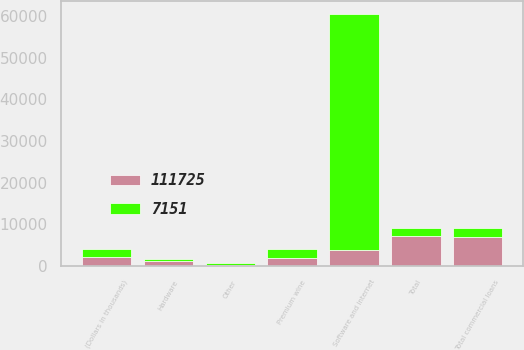Convert chart. <chart><loc_0><loc_0><loc_500><loc_500><stacked_bar_chart><ecel><fcel>(Dollars in thousands)<fcel>Software and internet<fcel>Hardware<fcel>Premium wine<fcel>Other<fcel>Total commercial loans<fcel>Total<nl><fcel>7151<fcel>2015<fcel>56790<fcel>473<fcel>2065<fcel>519<fcel>2014.5<fcel>2014.5<nl><fcel>111725<fcel>2014<fcel>3784<fcel>1118<fcel>1891<fcel>233<fcel>7026<fcel>7151<nl></chart> 